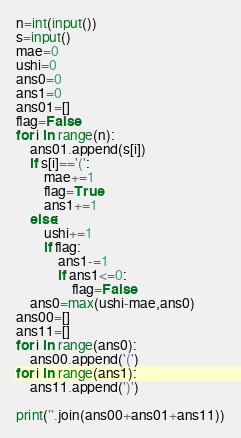Convert code to text. <code><loc_0><loc_0><loc_500><loc_500><_Python_>n=int(input())
s=input()
mae=0
ushi=0
ans0=0
ans1=0
ans01=[]
flag=False
for i in range(n):
    ans01.append(s[i])
    if s[i]=='(':
        mae+=1
        flag=True
        ans1+=1
    else:
        ushi+=1
        if flag:
            ans1-=1
            if ans1<=0:
                flag=False
    ans0=max(ushi-mae,ans0)
ans00=[]
ans11=[]
for i in range(ans0):
    ans00.append('(')
for i in range(ans1):
    ans11.append(')')

print(''.join(ans00+ans01+ans11))</code> 